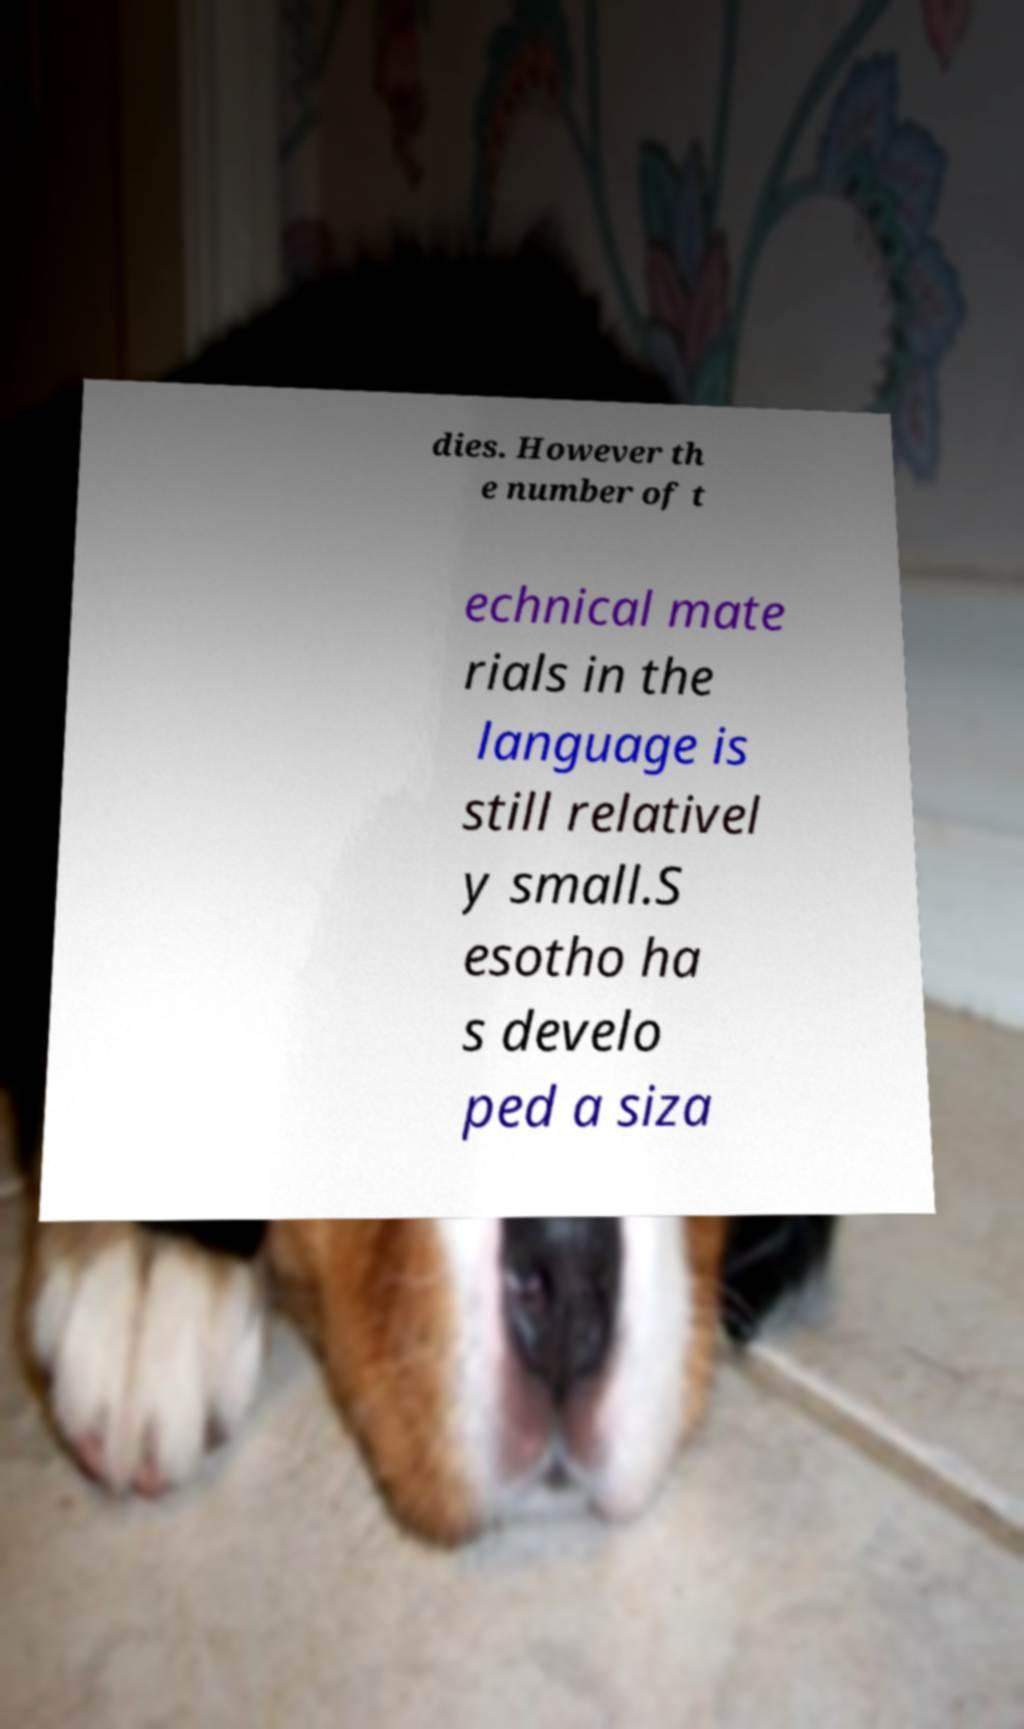There's text embedded in this image that I need extracted. Can you transcribe it verbatim? dies. However th e number of t echnical mate rials in the language is still relativel y small.S esotho ha s develo ped a siza 